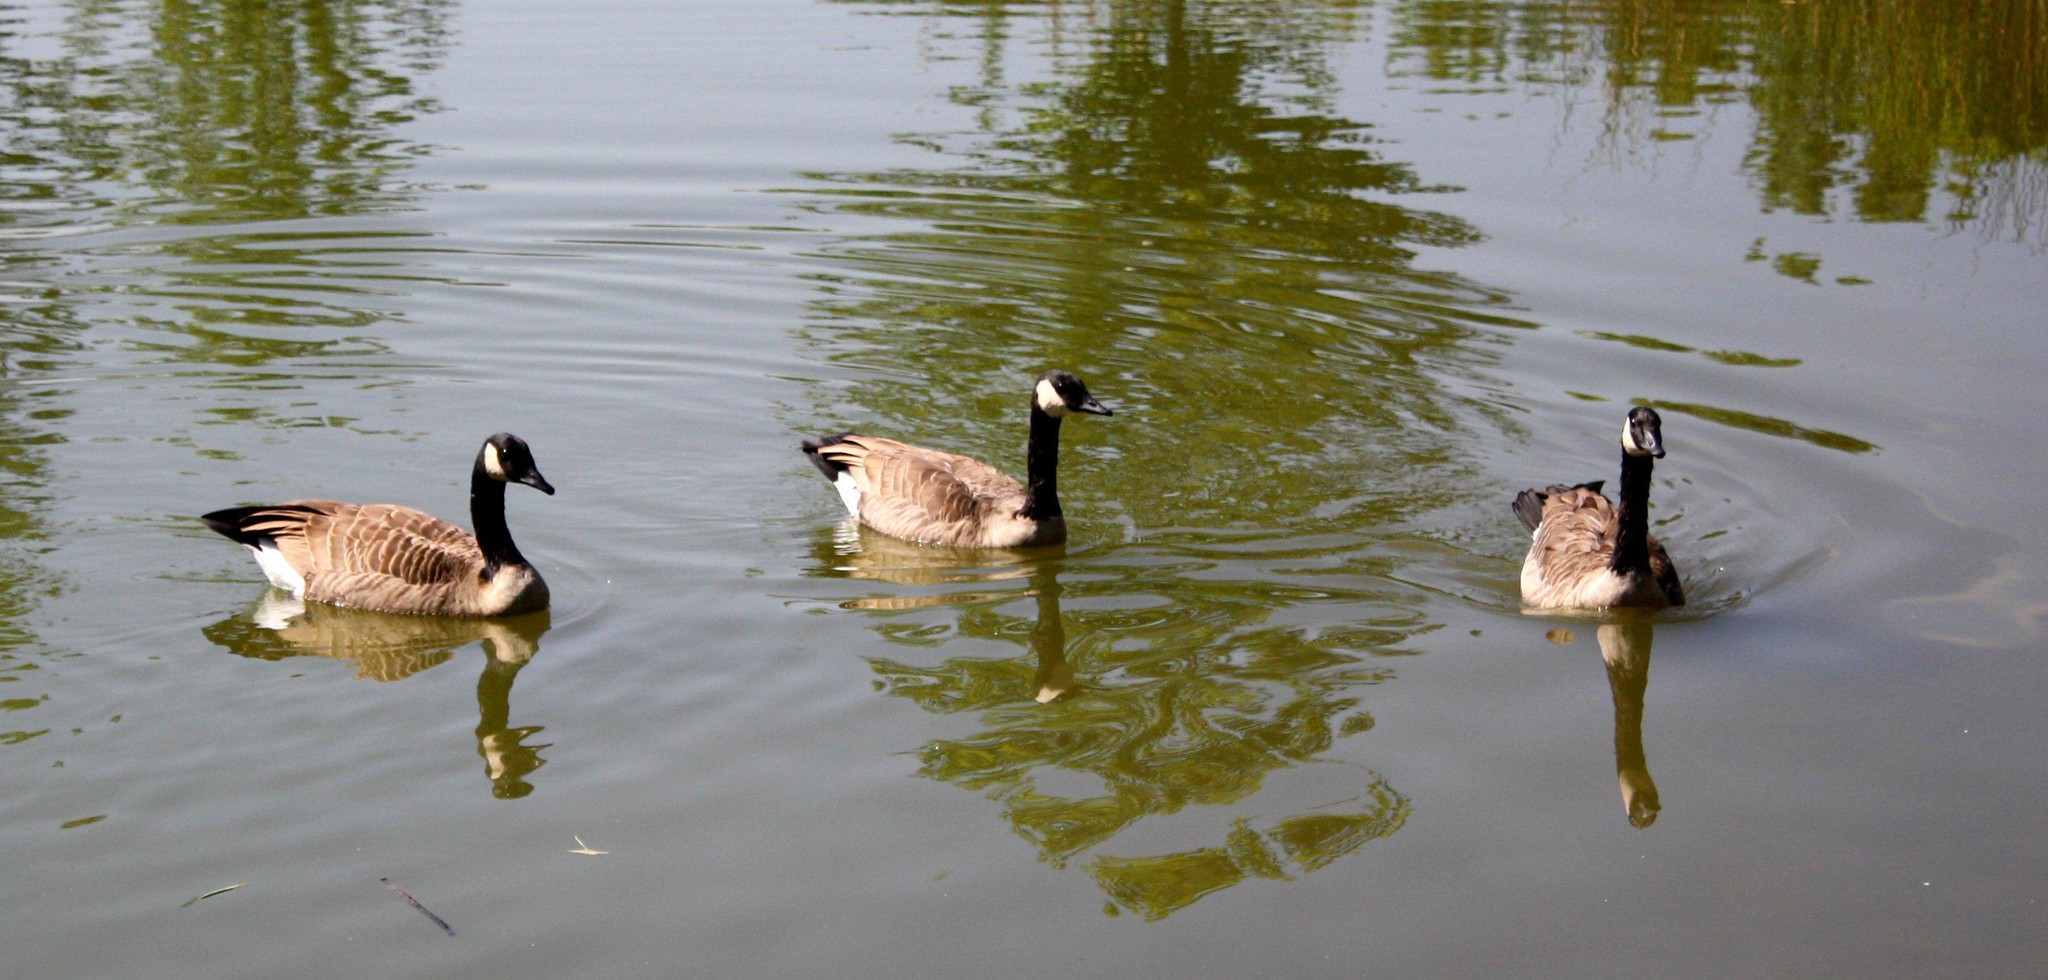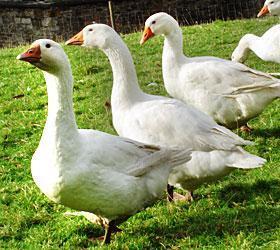The first image is the image on the left, the second image is the image on the right. Analyze the images presented: Is the assertion "Three birds float on a pool of water and none of them face leftward, in one image." valid? Answer yes or no. Yes. The first image is the image on the left, the second image is the image on the right. Analyze the images presented: Is the assertion "In the left image, three geese with orange beaks are floating on water" valid? Answer yes or no. No. 